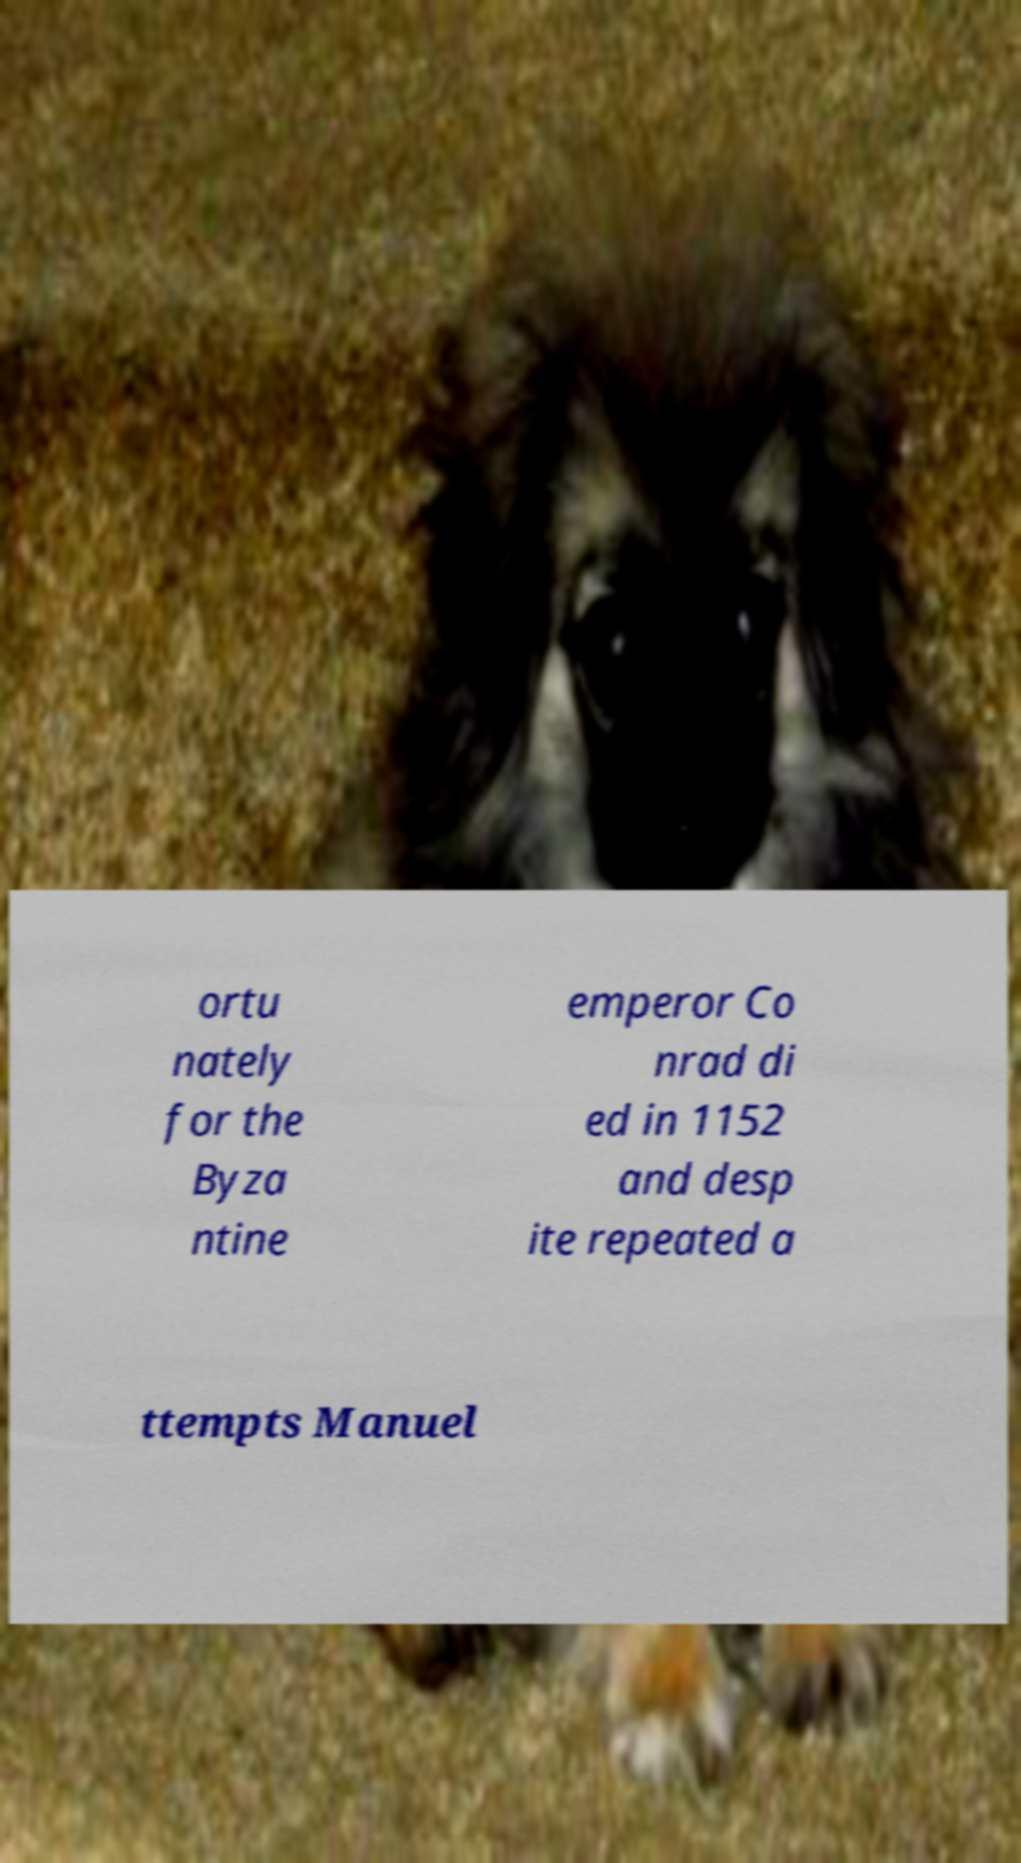Could you extract and type out the text from this image? ortu nately for the Byza ntine emperor Co nrad di ed in 1152 and desp ite repeated a ttempts Manuel 